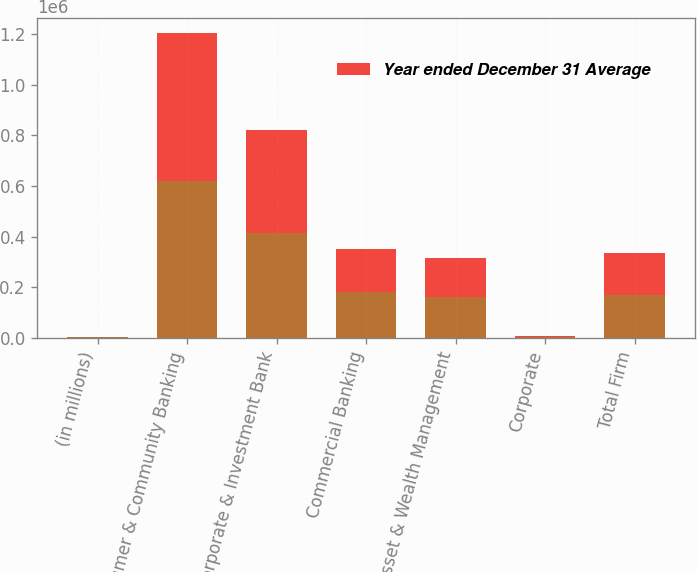<chart> <loc_0><loc_0><loc_500><loc_500><stacked_bar_chart><ecel><fcel>(in millions)<fcel>Consumer & Community Banking<fcel>Corporate & Investment Bank<fcel>Commercial Banking<fcel>Asset & Wealth Management<fcel>Corporate<fcel>Total Firm<nl><fcel>nan<fcel>2016<fcel>618337<fcel>412434<fcel>179532<fcel>161577<fcel>3299<fcel>167206<nl><fcel>Year ended December 31 Average<fcel>2016<fcel>586637<fcel>409680<fcel>172835<fcel>153334<fcel>5482<fcel>167206<nl></chart> 